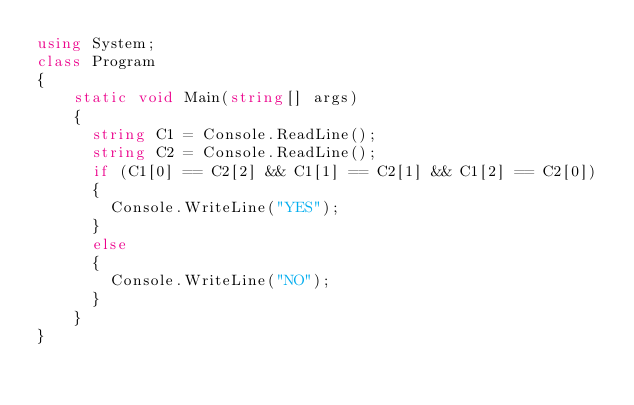Convert code to text. <code><loc_0><loc_0><loc_500><loc_500><_C#_>using System;
class Program
{
	static void Main(string[] args)
	{
      string C1 = Console.ReadLine();
      string C2 = Console.ReadLine();
      if (C1[0] == C2[2] && C1[1] == C2[1] && C1[2] == C2[0])
      {
        Console.WriteLine("YES");
      }
      else
      {
        Console.WriteLine("NO");       
      }
	}
}</code> 